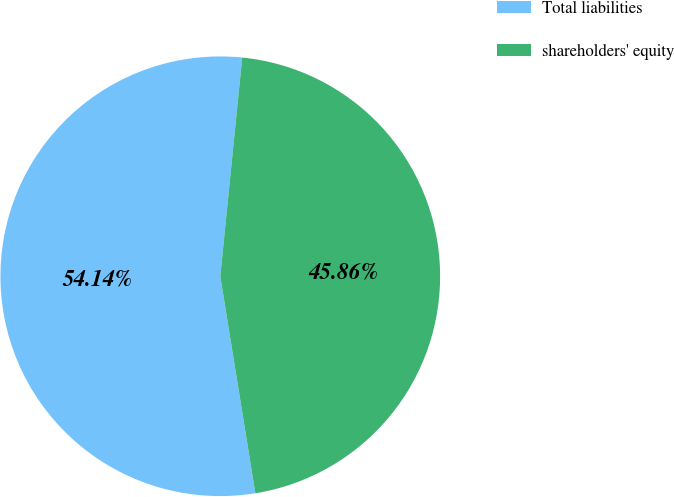<chart> <loc_0><loc_0><loc_500><loc_500><pie_chart><fcel>Total liabilities<fcel>shareholders' equity<nl><fcel>54.14%<fcel>45.86%<nl></chart> 